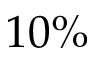<formula> <loc_0><loc_0><loc_500><loc_500>1 0 \%</formula> 